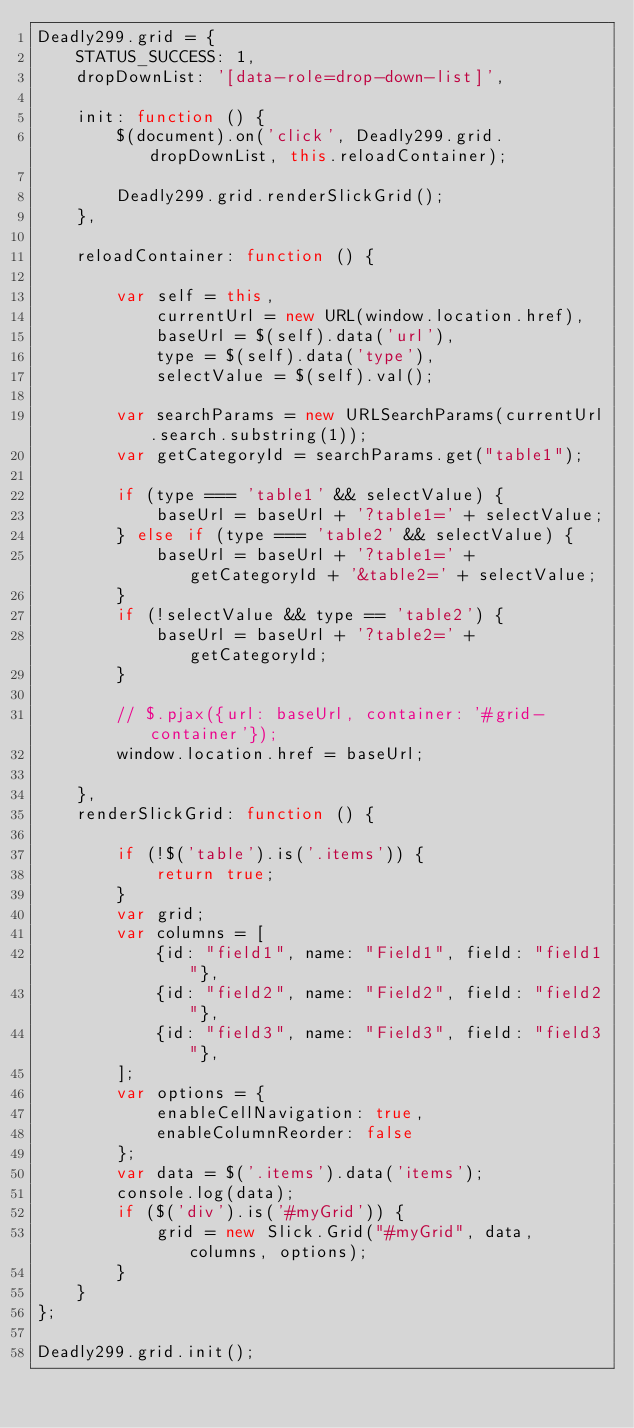<code> <loc_0><loc_0><loc_500><loc_500><_JavaScript_>Deadly299.grid = {
    STATUS_SUCCESS: 1,
    dropDownList: '[data-role=drop-down-list]',

    init: function () {
        $(document).on('click', Deadly299.grid.dropDownList, this.reloadContainer);

        Deadly299.grid.renderSlickGrid();
    },

    reloadContainer: function () {

        var self = this,
            currentUrl = new URL(window.location.href),
            baseUrl = $(self).data('url'),
            type = $(self).data('type'),
            selectValue = $(self).val();

        var searchParams = new URLSearchParams(currentUrl.search.substring(1));
        var getCategoryId = searchParams.get("table1");

        if (type === 'table1' && selectValue) {
            baseUrl = baseUrl + '?table1=' + selectValue;
        } else if (type === 'table2' && selectValue) {
            baseUrl = baseUrl + '?table1=' + getCategoryId + '&table2=' + selectValue;
        }
        if (!selectValue && type == 'table2') {
            baseUrl = baseUrl + '?table2=' + getCategoryId;
        }

        // $.pjax({url: baseUrl, container: '#grid-container'});
        window.location.href = baseUrl;

    },
    renderSlickGrid: function () {

        if (!$('table').is('.items')) {
            return true;
        }
        var grid;
        var columns = [
            {id: "field1", name: "Field1", field: "field1"},
            {id: "field2", name: "Field2", field: "field2"},
            {id: "field3", name: "Field3", field: "field3"},
        ];
        var options = {
            enableCellNavigation: true,
            enableColumnReorder: false
        };
        var data = $('.items').data('items');
        console.log(data);
        if ($('div').is('#myGrid')) {
            grid = new Slick.Grid("#myGrid", data, columns, options);
        }
    }
};

Deadly299.grid.init();</code> 